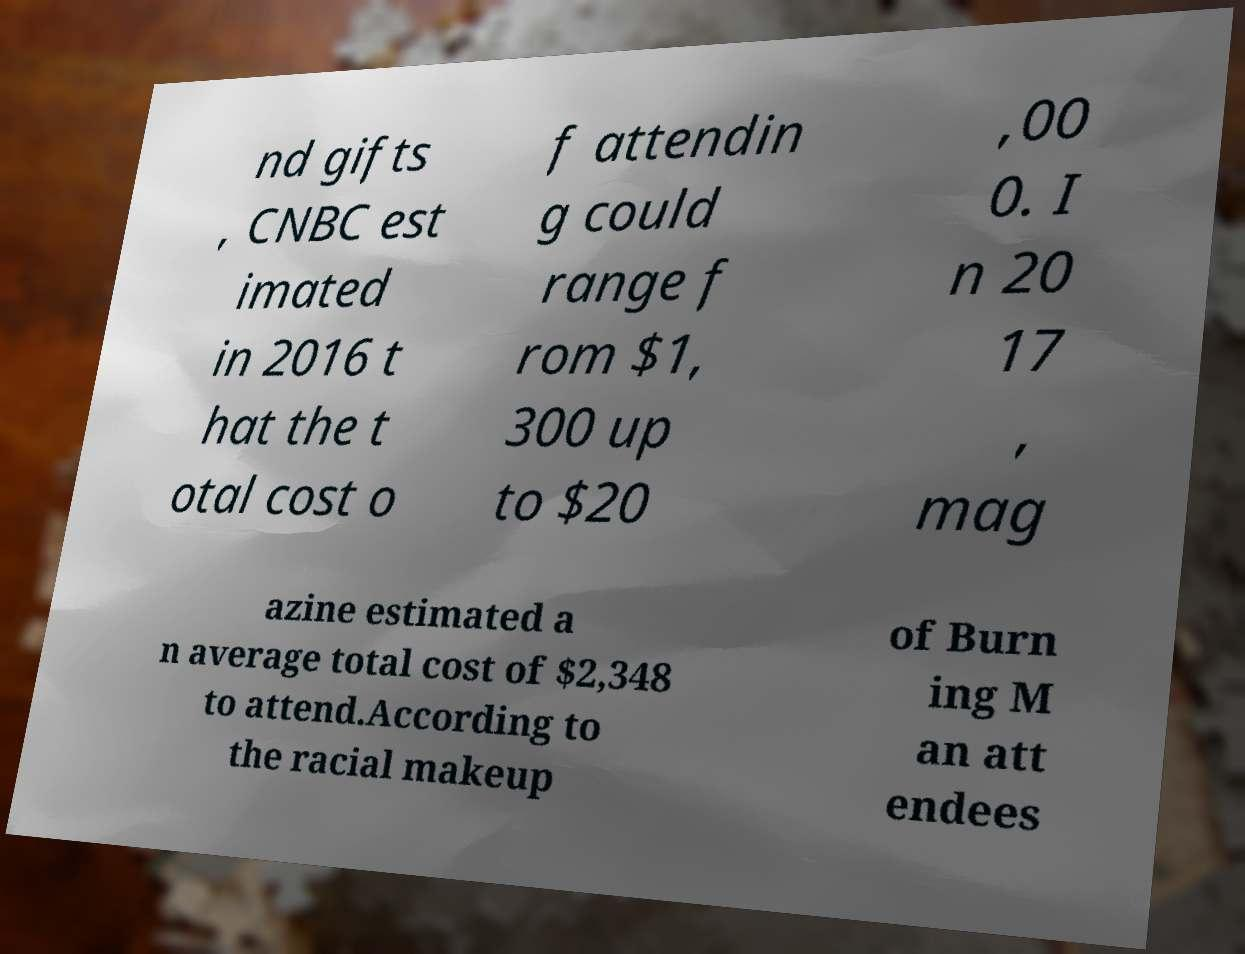Can you read and provide the text displayed in the image?This photo seems to have some interesting text. Can you extract and type it out for me? nd gifts , CNBC est imated in 2016 t hat the t otal cost o f attendin g could range f rom $1, 300 up to $20 ,00 0. I n 20 17 , mag azine estimated a n average total cost of $2,348 to attend.According to the racial makeup of Burn ing M an att endees 